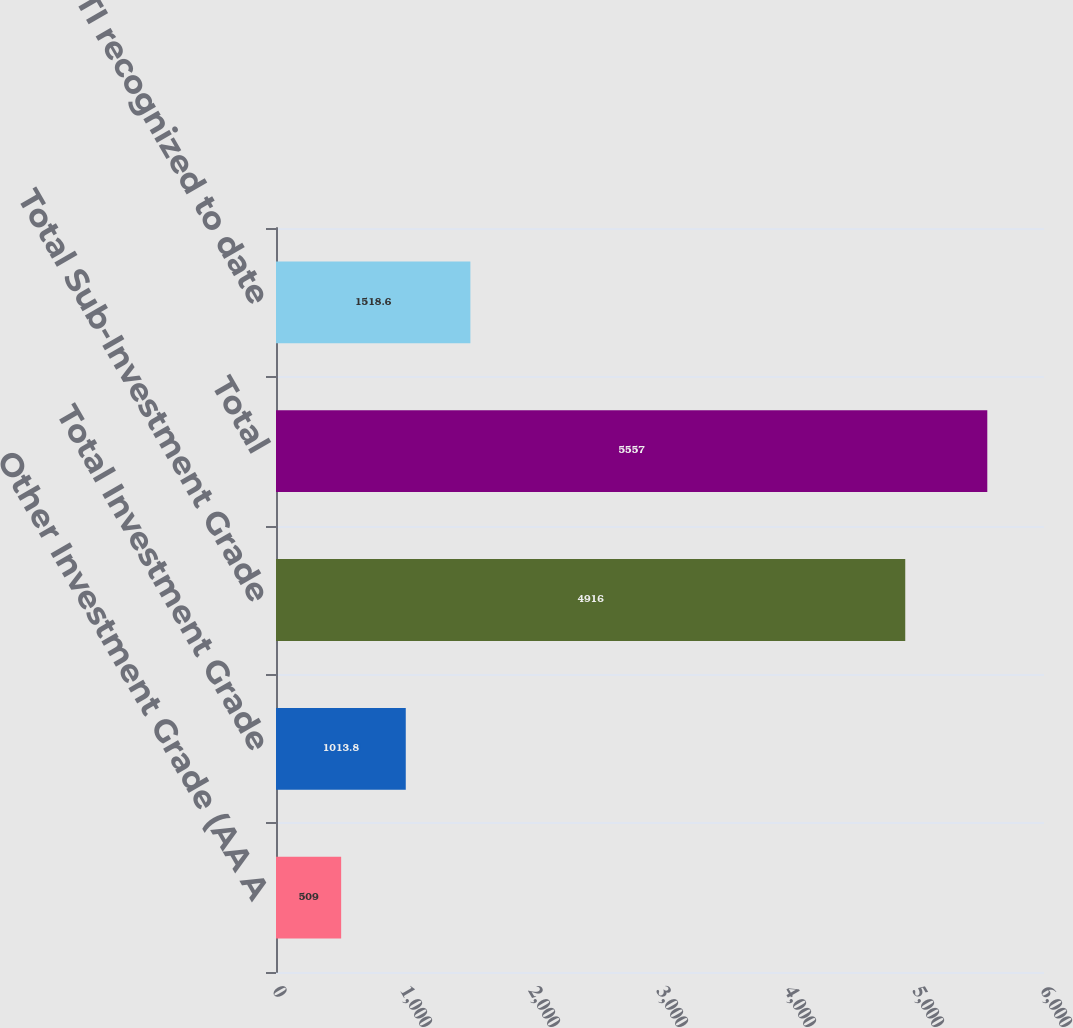Convert chart to OTSL. <chart><loc_0><loc_0><loc_500><loc_500><bar_chart><fcel>Other Investment Grade (AA A<fcel>Total Investment Grade<fcel>Total Sub-Investment Grade<fcel>Total<fcel>No OTTI recognized to date<nl><fcel>509<fcel>1013.8<fcel>4916<fcel>5557<fcel>1518.6<nl></chart> 